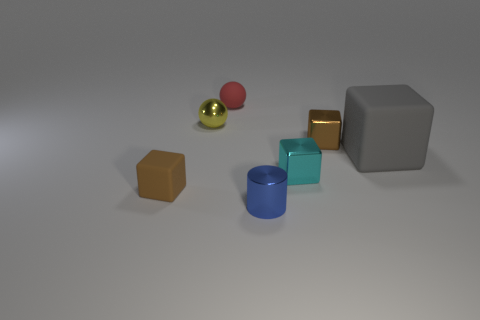Are there any other things that are the same size as the gray block?
Ensure brevity in your answer.  No. There is a brown cube on the right side of the shiny thing that is in front of the brown matte thing; is there a small rubber sphere that is in front of it?
Make the answer very short. No. How many big objects are cyan metal objects or green shiny things?
Your response must be concise. 0. Is there anything else that is the same color as the cylinder?
Offer a very short reply. No. There is a cylinder that is left of the cyan shiny cube; is its size the same as the small red thing?
Your answer should be very brief. Yes. What color is the rubber thing in front of the matte cube on the right side of the small matte object that is on the left side of the yellow metallic sphere?
Make the answer very short. Brown. The big block has what color?
Give a very brief answer. Gray. Does the tiny blue object that is in front of the small red sphere have the same material as the tiny brown thing that is to the right of the cylinder?
Offer a very short reply. Yes. There is another tiny object that is the same shape as the yellow object; what material is it?
Offer a terse response. Rubber. Is the material of the cylinder the same as the cyan thing?
Offer a terse response. Yes. 